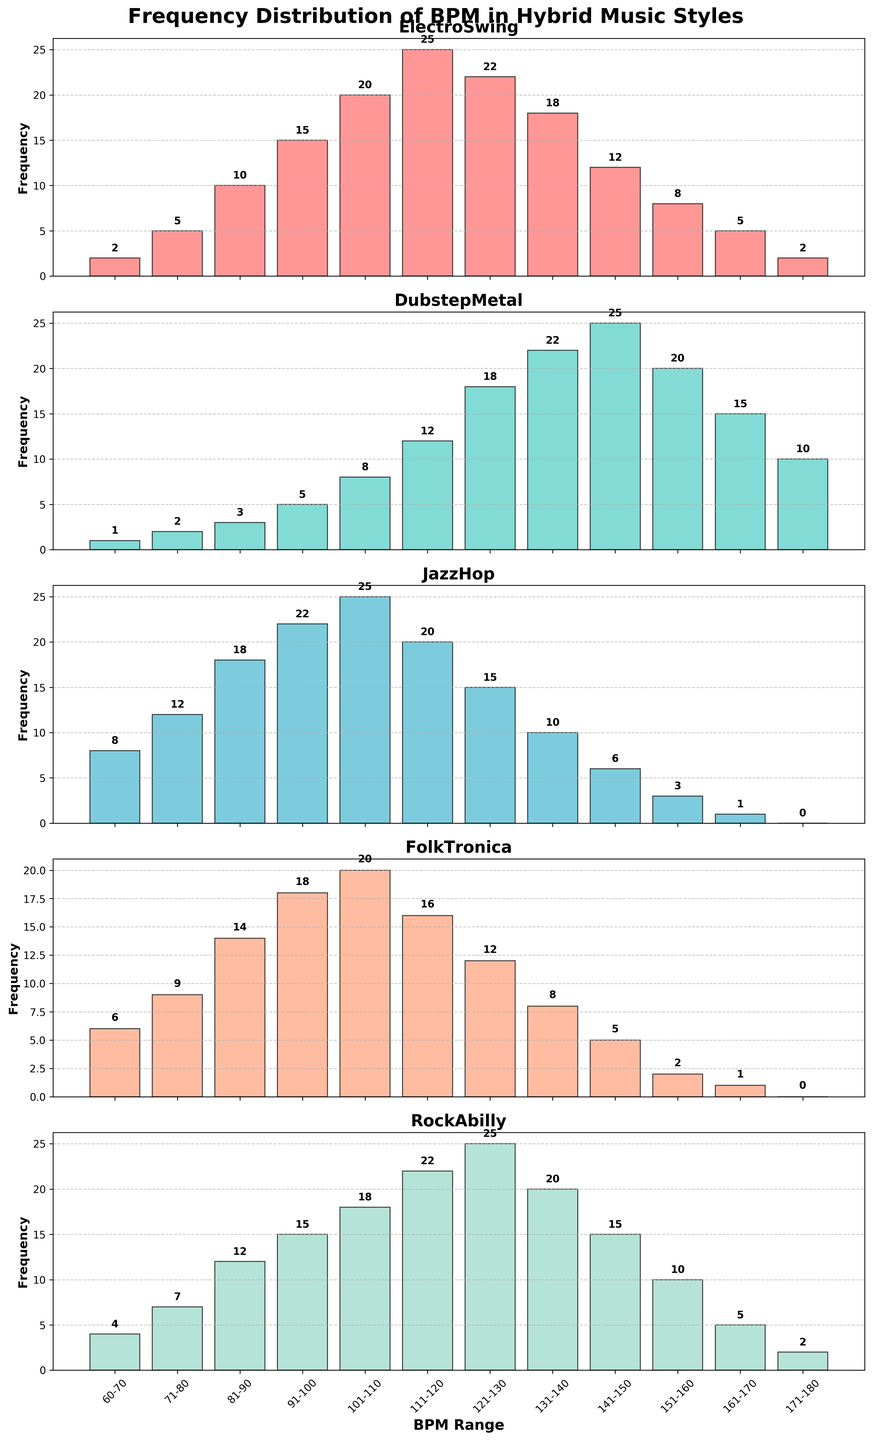What is the range of BPM with the highest frequency in the ElectroSwing genre? The range of BPM with the highest frequency in ElectroSwing can be determined by looking for the tallest bar in the ElectroSwing subplot. The tallest bar is in the range 111-120 BPM with a frequency of 25.
Answer: 111-120 BPM Which genre has the highest overall frequency in the 131-140 BPM range? To determine this, compare the heights of the bars for the 131-140 BPM range across all subplots. The tallest bar in this range belongs to DubstepMetal with a frequency of 22.
Answer: DubstepMetal In the JazzHop genre, what is the combined frequency of the 60-70 and 71-80 BPM ranges? Add the frequencies for the ranges 60-70 BPM and 71-80 BPM in the JazzHop subplot. The frequencies are 8 and 12, respectively, resulting in a combined frequency of 8+12=20.
Answer: 20 Which genre shows a decreasing trend in frequency as the BPM range increases from 121-130 to 161-170? Look for a subplot where the bar heights decrease consistently from 121-130 BPM to 161-170 BPM. The RockAbilly and JazzHop genres show this pattern, but focusing on RockAbilly for example, the frequencies are 25, 20, 15, 10, and 5, showing a consistent decrease.
Answer: RockAbilly How does the frequency in the range 91-100 BPM for FolkTronica compare with that of JazzHop? Compare the heights of the bars in the 91-100 BPM range for both FolkTronica and JazzHop. FolkTronica has a frequency of 18, while JazzHop has 22. JazzHop has a higher frequency by 4 units.
Answer: JazzHop What is the sum of frequencies for the highest BPM range (171-180) across all genres? Sum the frequencies for the 171-180 BPM range across all subplots. The frequencies are ElectroSwing: 2, DubstepMetal: 10, JazzHop: 0, FolkTronica: 0, RockAbilly: 2. The total is 2+10+0+0+2=14.
Answer: 14 For DubstepMetal, what is the difference in frequency between the 111-120 BPM and 151-160 BPM ranges? Subtract the frequency of the 151-160 BPM range from that of the 111-120 BPM range for DubstepMetal. The frequencies are 12 and 20, respectively, resulting in a difference of 12-8=4.
Answer: 4 Which BPM range appears most frequently across all genres? Identify which BPM range has the most occurrences of high frequencies when summing across all genres. Here, the range 111-120 BPM stands out as it frequently visualizes the highest frequencies combined across the genres.
Answer: 111-120 BPM 